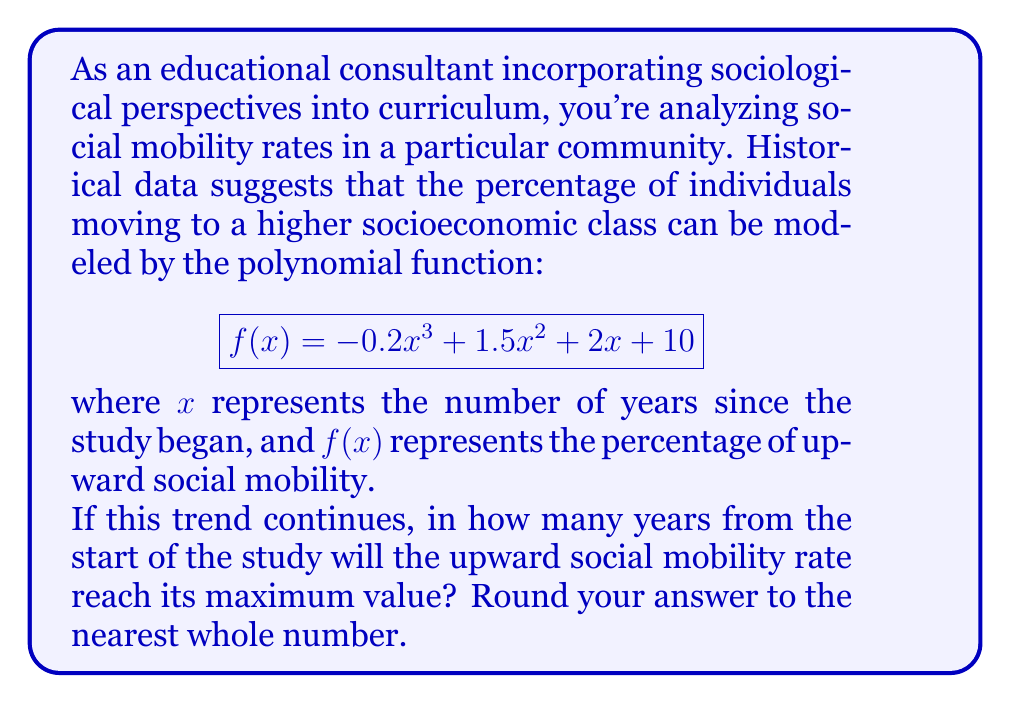Give your solution to this math problem. To find the maximum value of the function, we need to follow these steps:

1) First, we need to find the derivative of the function:
   $$ f'(x) = -0.6x^2 + 3x + 2 $$

2) To find the critical points, we set the derivative equal to zero:
   $$ -0.6x^2 + 3x + 2 = 0 $$

3) This is a quadratic equation. We can solve it using the quadratic formula:
   $$ x = \frac{-b \pm \sqrt{b^2 - 4ac}}{2a} $$
   where $a = -0.6$, $b = 3$, and $c = 2$

4) Plugging in these values:
   $$ x = \frac{-3 \pm \sqrt{3^2 - 4(-0.6)(2)}}{2(-0.6)} $$
   $$ = \frac{-3 \pm \sqrt{9 + 4.8}}{-1.2} $$
   $$ = \frac{-3 \pm \sqrt{13.8}}{-1.2} $$

5) Solving this:
   $$ x \approx 4.17 \text{ or } x \approx 0.83 $$

6) To determine which of these critical points gives us the maximum, we can check the second derivative:
   $$ f''(x) = -1.2x + 3 $$

7) Evaluating this at $x = 4.17$:
   $$ f''(4.17) = -1.2(4.17) + 3 \approx -2 < 0 $$

   This confirms that $x \approx 4.17$ gives us the maximum.

8) Rounding to the nearest whole number:
   $4.17 \approx 4$ years
Answer: 4 years 